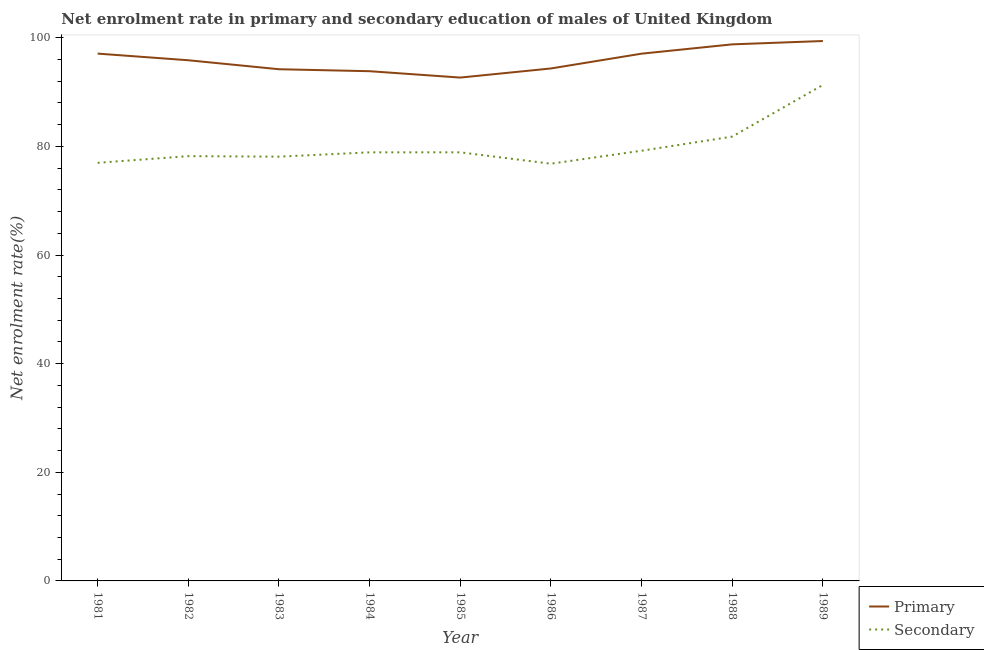What is the enrollment rate in secondary education in 1986?
Keep it short and to the point. 76.81. Across all years, what is the maximum enrollment rate in primary education?
Provide a short and direct response. 99.4. Across all years, what is the minimum enrollment rate in primary education?
Provide a short and direct response. 92.67. In which year was the enrollment rate in secondary education maximum?
Your answer should be very brief. 1989. In which year was the enrollment rate in primary education minimum?
Provide a succinct answer. 1985. What is the total enrollment rate in secondary education in the graph?
Your answer should be very brief. 720.22. What is the difference between the enrollment rate in secondary education in 1986 and that in 1988?
Your answer should be very brief. -4.99. What is the difference between the enrollment rate in secondary education in 1985 and the enrollment rate in primary education in 1984?
Your answer should be compact. -14.94. What is the average enrollment rate in primary education per year?
Keep it short and to the point. 95.92. In the year 1984, what is the difference between the enrollment rate in secondary education and enrollment rate in primary education?
Provide a short and direct response. -14.94. What is the ratio of the enrollment rate in secondary education in 1981 to that in 1988?
Provide a succinct answer. 0.94. Is the enrollment rate in secondary education in 1984 less than that in 1989?
Offer a terse response. Yes. What is the difference between the highest and the second highest enrollment rate in secondary education?
Make the answer very short. 9.51. What is the difference between the highest and the lowest enrollment rate in secondary education?
Your answer should be compact. 14.5. In how many years, is the enrollment rate in primary education greater than the average enrollment rate in primary education taken over all years?
Ensure brevity in your answer.  4. Is the sum of the enrollment rate in secondary education in 1986 and 1987 greater than the maximum enrollment rate in primary education across all years?
Make the answer very short. Yes. What is the difference between two consecutive major ticks on the Y-axis?
Keep it short and to the point. 20. Are the values on the major ticks of Y-axis written in scientific E-notation?
Keep it short and to the point. No. Does the graph contain any zero values?
Keep it short and to the point. No. Does the graph contain grids?
Provide a succinct answer. No. How many legend labels are there?
Offer a very short reply. 2. What is the title of the graph?
Ensure brevity in your answer.  Net enrolment rate in primary and secondary education of males of United Kingdom. Does "Money lenders" appear as one of the legend labels in the graph?
Keep it short and to the point. No. What is the label or title of the Y-axis?
Your answer should be compact. Net enrolment rate(%). What is the Net enrolment rate(%) of Primary in 1981?
Make the answer very short. 97.08. What is the Net enrolment rate(%) in Secondary in 1981?
Give a very brief answer. 76.98. What is the Net enrolment rate(%) of Primary in 1982?
Offer a terse response. 95.86. What is the Net enrolment rate(%) in Secondary in 1982?
Provide a succinct answer. 78.2. What is the Net enrolment rate(%) of Primary in 1983?
Provide a short and direct response. 94.21. What is the Net enrolment rate(%) of Secondary in 1983?
Offer a terse response. 78.11. What is the Net enrolment rate(%) in Primary in 1984?
Offer a very short reply. 93.84. What is the Net enrolment rate(%) of Secondary in 1984?
Offer a very short reply. 78.9. What is the Net enrolment rate(%) in Primary in 1985?
Your answer should be very brief. 92.67. What is the Net enrolment rate(%) in Secondary in 1985?
Your response must be concise. 78.91. What is the Net enrolment rate(%) in Primary in 1986?
Offer a terse response. 94.35. What is the Net enrolment rate(%) of Secondary in 1986?
Your response must be concise. 76.81. What is the Net enrolment rate(%) of Primary in 1987?
Give a very brief answer. 97.07. What is the Net enrolment rate(%) in Secondary in 1987?
Your response must be concise. 79.2. What is the Net enrolment rate(%) of Primary in 1988?
Offer a very short reply. 98.78. What is the Net enrolment rate(%) of Secondary in 1988?
Give a very brief answer. 81.8. What is the Net enrolment rate(%) in Primary in 1989?
Make the answer very short. 99.4. What is the Net enrolment rate(%) in Secondary in 1989?
Your response must be concise. 91.31. Across all years, what is the maximum Net enrolment rate(%) of Primary?
Offer a terse response. 99.4. Across all years, what is the maximum Net enrolment rate(%) in Secondary?
Your response must be concise. 91.31. Across all years, what is the minimum Net enrolment rate(%) in Primary?
Your answer should be very brief. 92.67. Across all years, what is the minimum Net enrolment rate(%) in Secondary?
Ensure brevity in your answer.  76.81. What is the total Net enrolment rate(%) of Primary in the graph?
Offer a terse response. 863.26. What is the total Net enrolment rate(%) in Secondary in the graph?
Ensure brevity in your answer.  720.22. What is the difference between the Net enrolment rate(%) of Primary in 1981 and that in 1982?
Provide a succinct answer. 1.23. What is the difference between the Net enrolment rate(%) in Secondary in 1981 and that in 1982?
Provide a succinct answer. -1.23. What is the difference between the Net enrolment rate(%) of Primary in 1981 and that in 1983?
Give a very brief answer. 2.88. What is the difference between the Net enrolment rate(%) of Secondary in 1981 and that in 1983?
Give a very brief answer. -1.13. What is the difference between the Net enrolment rate(%) of Primary in 1981 and that in 1984?
Make the answer very short. 3.24. What is the difference between the Net enrolment rate(%) in Secondary in 1981 and that in 1984?
Offer a terse response. -1.93. What is the difference between the Net enrolment rate(%) in Primary in 1981 and that in 1985?
Offer a terse response. 4.41. What is the difference between the Net enrolment rate(%) of Secondary in 1981 and that in 1985?
Ensure brevity in your answer.  -1.93. What is the difference between the Net enrolment rate(%) in Primary in 1981 and that in 1986?
Your response must be concise. 2.74. What is the difference between the Net enrolment rate(%) of Secondary in 1981 and that in 1986?
Offer a very short reply. 0.16. What is the difference between the Net enrolment rate(%) in Primary in 1981 and that in 1987?
Give a very brief answer. 0.01. What is the difference between the Net enrolment rate(%) of Secondary in 1981 and that in 1987?
Offer a very short reply. -2.23. What is the difference between the Net enrolment rate(%) in Primary in 1981 and that in 1988?
Provide a short and direct response. -1.7. What is the difference between the Net enrolment rate(%) of Secondary in 1981 and that in 1988?
Make the answer very short. -4.83. What is the difference between the Net enrolment rate(%) in Primary in 1981 and that in 1989?
Your answer should be compact. -2.32. What is the difference between the Net enrolment rate(%) of Secondary in 1981 and that in 1989?
Provide a short and direct response. -14.33. What is the difference between the Net enrolment rate(%) of Primary in 1982 and that in 1983?
Provide a short and direct response. 1.65. What is the difference between the Net enrolment rate(%) in Secondary in 1982 and that in 1983?
Your response must be concise. 0.1. What is the difference between the Net enrolment rate(%) in Primary in 1982 and that in 1984?
Your answer should be compact. 2.01. What is the difference between the Net enrolment rate(%) of Secondary in 1982 and that in 1984?
Provide a succinct answer. -0.7. What is the difference between the Net enrolment rate(%) in Primary in 1982 and that in 1985?
Your response must be concise. 3.19. What is the difference between the Net enrolment rate(%) in Secondary in 1982 and that in 1985?
Provide a succinct answer. -0.7. What is the difference between the Net enrolment rate(%) in Primary in 1982 and that in 1986?
Offer a very short reply. 1.51. What is the difference between the Net enrolment rate(%) in Secondary in 1982 and that in 1986?
Keep it short and to the point. 1.39. What is the difference between the Net enrolment rate(%) of Primary in 1982 and that in 1987?
Keep it short and to the point. -1.21. What is the difference between the Net enrolment rate(%) in Secondary in 1982 and that in 1987?
Offer a very short reply. -1. What is the difference between the Net enrolment rate(%) in Primary in 1982 and that in 1988?
Give a very brief answer. -2.93. What is the difference between the Net enrolment rate(%) of Secondary in 1982 and that in 1988?
Make the answer very short. -3.6. What is the difference between the Net enrolment rate(%) in Primary in 1982 and that in 1989?
Keep it short and to the point. -3.54. What is the difference between the Net enrolment rate(%) in Secondary in 1982 and that in 1989?
Ensure brevity in your answer.  -13.11. What is the difference between the Net enrolment rate(%) in Primary in 1983 and that in 1984?
Offer a terse response. 0.36. What is the difference between the Net enrolment rate(%) of Secondary in 1983 and that in 1984?
Your answer should be very brief. -0.8. What is the difference between the Net enrolment rate(%) in Primary in 1983 and that in 1985?
Keep it short and to the point. 1.54. What is the difference between the Net enrolment rate(%) of Secondary in 1983 and that in 1985?
Your response must be concise. -0.8. What is the difference between the Net enrolment rate(%) of Primary in 1983 and that in 1986?
Your answer should be very brief. -0.14. What is the difference between the Net enrolment rate(%) in Secondary in 1983 and that in 1986?
Your response must be concise. 1.3. What is the difference between the Net enrolment rate(%) in Primary in 1983 and that in 1987?
Offer a very short reply. -2.86. What is the difference between the Net enrolment rate(%) of Secondary in 1983 and that in 1987?
Make the answer very short. -1.09. What is the difference between the Net enrolment rate(%) of Primary in 1983 and that in 1988?
Provide a succinct answer. -4.58. What is the difference between the Net enrolment rate(%) of Secondary in 1983 and that in 1988?
Provide a succinct answer. -3.7. What is the difference between the Net enrolment rate(%) in Primary in 1983 and that in 1989?
Provide a short and direct response. -5.2. What is the difference between the Net enrolment rate(%) of Secondary in 1983 and that in 1989?
Your answer should be compact. -13.2. What is the difference between the Net enrolment rate(%) of Primary in 1984 and that in 1985?
Your answer should be compact. 1.17. What is the difference between the Net enrolment rate(%) in Secondary in 1984 and that in 1985?
Keep it short and to the point. -0. What is the difference between the Net enrolment rate(%) of Primary in 1984 and that in 1986?
Ensure brevity in your answer.  -0.51. What is the difference between the Net enrolment rate(%) in Secondary in 1984 and that in 1986?
Provide a succinct answer. 2.09. What is the difference between the Net enrolment rate(%) of Primary in 1984 and that in 1987?
Provide a succinct answer. -3.23. What is the difference between the Net enrolment rate(%) of Secondary in 1984 and that in 1987?
Give a very brief answer. -0.3. What is the difference between the Net enrolment rate(%) in Primary in 1984 and that in 1988?
Provide a short and direct response. -4.94. What is the difference between the Net enrolment rate(%) in Secondary in 1984 and that in 1988?
Your response must be concise. -2.9. What is the difference between the Net enrolment rate(%) in Primary in 1984 and that in 1989?
Provide a short and direct response. -5.56. What is the difference between the Net enrolment rate(%) in Secondary in 1984 and that in 1989?
Make the answer very short. -12.41. What is the difference between the Net enrolment rate(%) in Primary in 1985 and that in 1986?
Your answer should be compact. -1.68. What is the difference between the Net enrolment rate(%) in Secondary in 1985 and that in 1986?
Provide a succinct answer. 2.1. What is the difference between the Net enrolment rate(%) in Primary in 1985 and that in 1987?
Offer a very short reply. -4.4. What is the difference between the Net enrolment rate(%) of Secondary in 1985 and that in 1987?
Keep it short and to the point. -0.29. What is the difference between the Net enrolment rate(%) of Primary in 1985 and that in 1988?
Give a very brief answer. -6.11. What is the difference between the Net enrolment rate(%) of Secondary in 1985 and that in 1988?
Your answer should be very brief. -2.9. What is the difference between the Net enrolment rate(%) of Primary in 1985 and that in 1989?
Provide a short and direct response. -6.73. What is the difference between the Net enrolment rate(%) of Secondary in 1985 and that in 1989?
Ensure brevity in your answer.  -12.4. What is the difference between the Net enrolment rate(%) in Primary in 1986 and that in 1987?
Give a very brief answer. -2.72. What is the difference between the Net enrolment rate(%) of Secondary in 1986 and that in 1987?
Offer a terse response. -2.39. What is the difference between the Net enrolment rate(%) in Primary in 1986 and that in 1988?
Provide a succinct answer. -4.44. What is the difference between the Net enrolment rate(%) in Secondary in 1986 and that in 1988?
Your answer should be compact. -4.99. What is the difference between the Net enrolment rate(%) of Primary in 1986 and that in 1989?
Make the answer very short. -5.05. What is the difference between the Net enrolment rate(%) in Secondary in 1986 and that in 1989?
Give a very brief answer. -14.5. What is the difference between the Net enrolment rate(%) of Primary in 1987 and that in 1988?
Offer a very short reply. -1.71. What is the difference between the Net enrolment rate(%) of Secondary in 1987 and that in 1988?
Keep it short and to the point. -2.6. What is the difference between the Net enrolment rate(%) in Primary in 1987 and that in 1989?
Your answer should be compact. -2.33. What is the difference between the Net enrolment rate(%) in Secondary in 1987 and that in 1989?
Make the answer very short. -12.11. What is the difference between the Net enrolment rate(%) in Primary in 1988 and that in 1989?
Ensure brevity in your answer.  -0.62. What is the difference between the Net enrolment rate(%) in Secondary in 1988 and that in 1989?
Provide a succinct answer. -9.51. What is the difference between the Net enrolment rate(%) of Primary in 1981 and the Net enrolment rate(%) of Secondary in 1982?
Provide a short and direct response. 18.88. What is the difference between the Net enrolment rate(%) in Primary in 1981 and the Net enrolment rate(%) in Secondary in 1983?
Ensure brevity in your answer.  18.98. What is the difference between the Net enrolment rate(%) of Primary in 1981 and the Net enrolment rate(%) of Secondary in 1984?
Your response must be concise. 18.18. What is the difference between the Net enrolment rate(%) of Primary in 1981 and the Net enrolment rate(%) of Secondary in 1985?
Make the answer very short. 18.18. What is the difference between the Net enrolment rate(%) of Primary in 1981 and the Net enrolment rate(%) of Secondary in 1986?
Give a very brief answer. 20.27. What is the difference between the Net enrolment rate(%) in Primary in 1981 and the Net enrolment rate(%) in Secondary in 1987?
Offer a terse response. 17.88. What is the difference between the Net enrolment rate(%) in Primary in 1981 and the Net enrolment rate(%) in Secondary in 1988?
Give a very brief answer. 15.28. What is the difference between the Net enrolment rate(%) in Primary in 1981 and the Net enrolment rate(%) in Secondary in 1989?
Offer a very short reply. 5.77. What is the difference between the Net enrolment rate(%) in Primary in 1982 and the Net enrolment rate(%) in Secondary in 1983?
Your answer should be very brief. 17.75. What is the difference between the Net enrolment rate(%) of Primary in 1982 and the Net enrolment rate(%) of Secondary in 1984?
Your response must be concise. 16.95. What is the difference between the Net enrolment rate(%) of Primary in 1982 and the Net enrolment rate(%) of Secondary in 1985?
Give a very brief answer. 16.95. What is the difference between the Net enrolment rate(%) of Primary in 1982 and the Net enrolment rate(%) of Secondary in 1986?
Your response must be concise. 19.05. What is the difference between the Net enrolment rate(%) of Primary in 1982 and the Net enrolment rate(%) of Secondary in 1987?
Your answer should be compact. 16.66. What is the difference between the Net enrolment rate(%) of Primary in 1982 and the Net enrolment rate(%) of Secondary in 1988?
Make the answer very short. 14.05. What is the difference between the Net enrolment rate(%) of Primary in 1982 and the Net enrolment rate(%) of Secondary in 1989?
Provide a short and direct response. 4.55. What is the difference between the Net enrolment rate(%) of Primary in 1983 and the Net enrolment rate(%) of Secondary in 1984?
Provide a succinct answer. 15.3. What is the difference between the Net enrolment rate(%) in Primary in 1983 and the Net enrolment rate(%) in Secondary in 1985?
Your response must be concise. 15.3. What is the difference between the Net enrolment rate(%) in Primary in 1983 and the Net enrolment rate(%) in Secondary in 1986?
Provide a succinct answer. 17.39. What is the difference between the Net enrolment rate(%) of Primary in 1983 and the Net enrolment rate(%) of Secondary in 1987?
Make the answer very short. 15. What is the difference between the Net enrolment rate(%) of Primary in 1983 and the Net enrolment rate(%) of Secondary in 1988?
Your response must be concise. 12.4. What is the difference between the Net enrolment rate(%) in Primary in 1983 and the Net enrolment rate(%) in Secondary in 1989?
Keep it short and to the point. 2.9. What is the difference between the Net enrolment rate(%) in Primary in 1984 and the Net enrolment rate(%) in Secondary in 1985?
Your response must be concise. 14.94. What is the difference between the Net enrolment rate(%) of Primary in 1984 and the Net enrolment rate(%) of Secondary in 1986?
Your response must be concise. 17.03. What is the difference between the Net enrolment rate(%) in Primary in 1984 and the Net enrolment rate(%) in Secondary in 1987?
Ensure brevity in your answer.  14.64. What is the difference between the Net enrolment rate(%) of Primary in 1984 and the Net enrolment rate(%) of Secondary in 1988?
Your answer should be very brief. 12.04. What is the difference between the Net enrolment rate(%) in Primary in 1984 and the Net enrolment rate(%) in Secondary in 1989?
Provide a succinct answer. 2.53. What is the difference between the Net enrolment rate(%) in Primary in 1985 and the Net enrolment rate(%) in Secondary in 1986?
Offer a very short reply. 15.86. What is the difference between the Net enrolment rate(%) in Primary in 1985 and the Net enrolment rate(%) in Secondary in 1987?
Your answer should be very brief. 13.47. What is the difference between the Net enrolment rate(%) of Primary in 1985 and the Net enrolment rate(%) of Secondary in 1988?
Your answer should be very brief. 10.87. What is the difference between the Net enrolment rate(%) of Primary in 1985 and the Net enrolment rate(%) of Secondary in 1989?
Your answer should be compact. 1.36. What is the difference between the Net enrolment rate(%) in Primary in 1986 and the Net enrolment rate(%) in Secondary in 1987?
Your response must be concise. 15.15. What is the difference between the Net enrolment rate(%) of Primary in 1986 and the Net enrolment rate(%) of Secondary in 1988?
Your answer should be very brief. 12.54. What is the difference between the Net enrolment rate(%) in Primary in 1986 and the Net enrolment rate(%) in Secondary in 1989?
Offer a very short reply. 3.04. What is the difference between the Net enrolment rate(%) in Primary in 1987 and the Net enrolment rate(%) in Secondary in 1988?
Your response must be concise. 15.27. What is the difference between the Net enrolment rate(%) of Primary in 1987 and the Net enrolment rate(%) of Secondary in 1989?
Offer a terse response. 5.76. What is the difference between the Net enrolment rate(%) of Primary in 1988 and the Net enrolment rate(%) of Secondary in 1989?
Keep it short and to the point. 7.47. What is the average Net enrolment rate(%) in Primary per year?
Provide a short and direct response. 95.92. What is the average Net enrolment rate(%) in Secondary per year?
Ensure brevity in your answer.  80.02. In the year 1981, what is the difference between the Net enrolment rate(%) of Primary and Net enrolment rate(%) of Secondary?
Your answer should be compact. 20.11. In the year 1982, what is the difference between the Net enrolment rate(%) of Primary and Net enrolment rate(%) of Secondary?
Ensure brevity in your answer.  17.65. In the year 1983, what is the difference between the Net enrolment rate(%) in Primary and Net enrolment rate(%) in Secondary?
Give a very brief answer. 16.1. In the year 1984, what is the difference between the Net enrolment rate(%) of Primary and Net enrolment rate(%) of Secondary?
Your answer should be compact. 14.94. In the year 1985, what is the difference between the Net enrolment rate(%) in Primary and Net enrolment rate(%) in Secondary?
Your answer should be very brief. 13.76. In the year 1986, what is the difference between the Net enrolment rate(%) in Primary and Net enrolment rate(%) in Secondary?
Give a very brief answer. 17.54. In the year 1987, what is the difference between the Net enrolment rate(%) in Primary and Net enrolment rate(%) in Secondary?
Your answer should be very brief. 17.87. In the year 1988, what is the difference between the Net enrolment rate(%) of Primary and Net enrolment rate(%) of Secondary?
Give a very brief answer. 16.98. In the year 1989, what is the difference between the Net enrolment rate(%) of Primary and Net enrolment rate(%) of Secondary?
Your answer should be very brief. 8.09. What is the ratio of the Net enrolment rate(%) in Primary in 1981 to that in 1982?
Keep it short and to the point. 1.01. What is the ratio of the Net enrolment rate(%) of Secondary in 1981 to that in 1982?
Keep it short and to the point. 0.98. What is the ratio of the Net enrolment rate(%) in Primary in 1981 to that in 1983?
Your response must be concise. 1.03. What is the ratio of the Net enrolment rate(%) of Secondary in 1981 to that in 1983?
Give a very brief answer. 0.99. What is the ratio of the Net enrolment rate(%) in Primary in 1981 to that in 1984?
Your response must be concise. 1.03. What is the ratio of the Net enrolment rate(%) in Secondary in 1981 to that in 1984?
Ensure brevity in your answer.  0.98. What is the ratio of the Net enrolment rate(%) of Primary in 1981 to that in 1985?
Keep it short and to the point. 1.05. What is the ratio of the Net enrolment rate(%) in Secondary in 1981 to that in 1985?
Provide a succinct answer. 0.98. What is the ratio of the Net enrolment rate(%) in Primary in 1981 to that in 1986?
Provide a succinct answer. 1.03. What is the ratio of the Net enrolment rate(%) in Primary in 1981 to that in 1987?
Give a very brief answer. 1. What is the ratio of the Net enrolment rate(%) of Secondary in 1981 to that in 1987?
Keep it short and to the point. 0.97. What is the ratio of the Net enrolment rate(%) in Primary in 1981 to that in 1988?
Your response must be concise. 0.98. What is the ratio of the Net enrolment rate(%) of Secondary in 1981 to that in 1988?
Offer a terse response. 0.94. What is the ratio of the Net enrolment rate(%) of Primary in 1981 to that in 1989?
Provide a succinct answer. 0.98. What is the ratio of the Net enrolment rate(%) of Secondary in 1981 to that in 1989?
Provide a succinct answer. 0.84. What is the ratio of the Net enrolment rate(%) in Primary in 1982 to that in 1983?
Offer a very short reply. 1.02. What is the ratio of the Net enrolment rate(%) of Primary in 1982 to that in 1984?
Offer a very short reply. 1.02. What is the ratio of the Net enrolment rate(%) of Primary in 1982 to that in 1985?
Offer a very short reply. 1.03. What is the ratio of the Net enrolment rate(%) in Secondary in 1982 to that in 1986?
Ensure brevity in your answer.  1.02. What is the ratio of the Net enrolment rate(%) in Primary in 1982 to that in 1987?
Keep it short and to the point. 0.99. What is the ratio of the Net enrolment rate(%) in Secondary in 1982 to that in 1987?
Offer a very short reply. 0.99. What is the ratio of the Net enrolment rate(%) of Primary in 1982 to that in 1988?
Ensure brevity in your answer.  0.97. What is the ratio of the Net enrolment rate(%) in Secondary in 1982 to that in 1988?
Give a very brief answer. 0.96. What is the ratio of the Net enrolment rate(%) of Primary in 1982 to that in 1989?
Ensure brevity in your answer.  0.96. What is the ratio of the Net enrolment rate(%) of Secondary in 1982 to that in 1989?
Keep it short and to the point. 0.86. What is the ratio of the Net enrolment rate(%) of Primary in 1983 to that in 1985?
Your answer should be compact. 1.02. What is the ratio of the Net enrolment rate(%) in Primary in 1983 to that in 1986?
Your answer should be very brief. 1. What is the ratio of the Net enrolment rate(%) in Secondary in 1983 to that in 1986?
Offer a terse response. 1.02. What is the ratio of the Net enrolment rate(%) of Primary in 1983 to that in 1987?
Make the answer very short. 0.97. What is the ratio of the Net enrolment rate(%) in Secondary in 1983 to that in 1987?
Keep it short and to the point. 0.99. What is the ratio of the Net enrolment rate(%) of Primary in 1983 to that in 1988?
Ensure brevity in your answer.  0.95. What is the ratio of the Net enrolment rate(%) of Secondary in 1983 to that in 1988?
Your answer should be very brief. 0.95. What is the ratio of the Net enrolment rate(%) in Primary in 1983 to that in 1989?
Your answer should be compact. 0.95. What is the ratio of the Net enrolment rate(%) of Secondary in 1983 to that in 1989?
Keep it short and to the point. 0.86. What is the ratio of the Net enrolment rate(%) in Primary in 1984 to that in 1985?
Ensure brevity in your answer.  1.01. What is the ratio of the Net enrolment rate(%) of Secondary in 1984 to that in 1985?
Your answer should be very brief. 1. What is the ratio of the Net enrolment rate(%) in Primary in 1984 to that in 1986?
Offer a terse response. 0.99. What is the ratio of the Net enrolment rate(%) in Secondary in 1984 to that in 1986?
Provide a succinct answer. 1.03. What is the ratio of the Net enrolment rate(%) in Primary in 1984 to that in 1987?
Offer a terse response. 0.97. What is the ratio of the Net enrolment rate(%) in Secondary in 1984 to that in 1987?
Make the answer very short. 1. What is the ratio of the Net enrolment rate(%) of Primary in 1984 to that in 1988?
Keep it short and to the point. 0.95. What is the ratio of the Net enrolment rate(%) of Secondary in 1984 to that in 1988?
Your answer should be compact. 0.96. What is the ratio of the Net enrolment rate(%) in Primary in 1984 to that in 1989?
Make the answer very short. 0.94. What is the ratio of the Net enrolment rate(%) of Secondary in 1984 to that in 1989?
Provide a succinct answer. 0.86. What is the ratio of the Net enrolment rate(%) in Primary in 1985 to that in 1986?
Your response must be concise. 0.98. What is the ratio of the Net enrolment rate(%) in Secondary in 1985 to that in 1986?
Give a very brief answer. 1.03. What is the ratio of the Net enrolment rate(%) in Primary in 1985 to that in 1987?
Offer a terse response. 0.95. What is the ratio of the Net enrolment rate(%) in Primary in 1985 to that in 1988?
Keep it short and to the point. 0.94. What is the ratio of the Net enrolment rate(%) in Secondary in 1985 to that in 1988?
Provide a succinct answer. 0.96. What is the ratio of the Net enrolment rate(%) of Primary in 1985 to that in 1989?
Provide a succinct answer. 0.93. What is the ratio of the Net enrolment rate(%) of Secondary in 1985 to that in 1989?
Provide a succinct answer. 0.86. What is the ratio of the Net enrolment rate(%) in Primary in 1986 to that in 1987?
Provide a short and direct response. 0.97. What is the ratio of the Net enrolment rate(%) of Secondary in 1986 to that in 1987?
Give a very brief answer. 0.97. What is the ratio of the Net enrolment rate(%) in Primary in 1986 to that in 1988?
Your answer should be very brief. 0.96. What is the ratio of the Net enrolment rate(%) of Secondary in 1986 to that in 1988?
Make the answer very short. 0.94. What is the ratio of the Net enrolment rate(%) in Primary in 1986 to that in 1989?
Offer a terse response. 0.95. What is the ratio of the Net enrolment rate(%) of Secondary in 1986 to that in 1989?
Provide a succinct answer. 0.84. What is the ratio of the Net enrolment rate(%) of Primary in 1987 to that in 1988?
Provide a short and direct response. 0.98. What is the ratio of the Net enrolment rate(%) in Secondary in 1987 to that in 1988?
Make the answer very short. 0.97. What is the ratio of the Net enrolment rate(%) in Primary in 1987 to that in 1989?
Your answer should be very brief. 0.98. What is the ratio of the Net enrolment rate(%) of Secondary in 1987 to that in 1989?
Your response must be concise. 0.87. What is the ratio of the Net enrolment rate(%) in Secondary in 1988 to that in 1989?
Offer a terse response. 0.9. What is the difference between the highest and the second highest Net enrolment rate(%) of Primary?
Provide a succinct answer. 0.62. What is the difference between the highest and the second highest Net enrolment rate(%) in Secondary?
Offer a terse response. 9.51. What is the difference between the highest and the lowest Net enrolment rate(%) of Primary?
Your answer should be compact. 6.73. What is the difference between the highest and the lowest Net enrolment rate(%) in Secondary?
Ensure brevity in your answer.  14.5. 